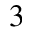<formula> <loc_0><loc_0><loc_500><loc_500>^ { 3 }</formula> 